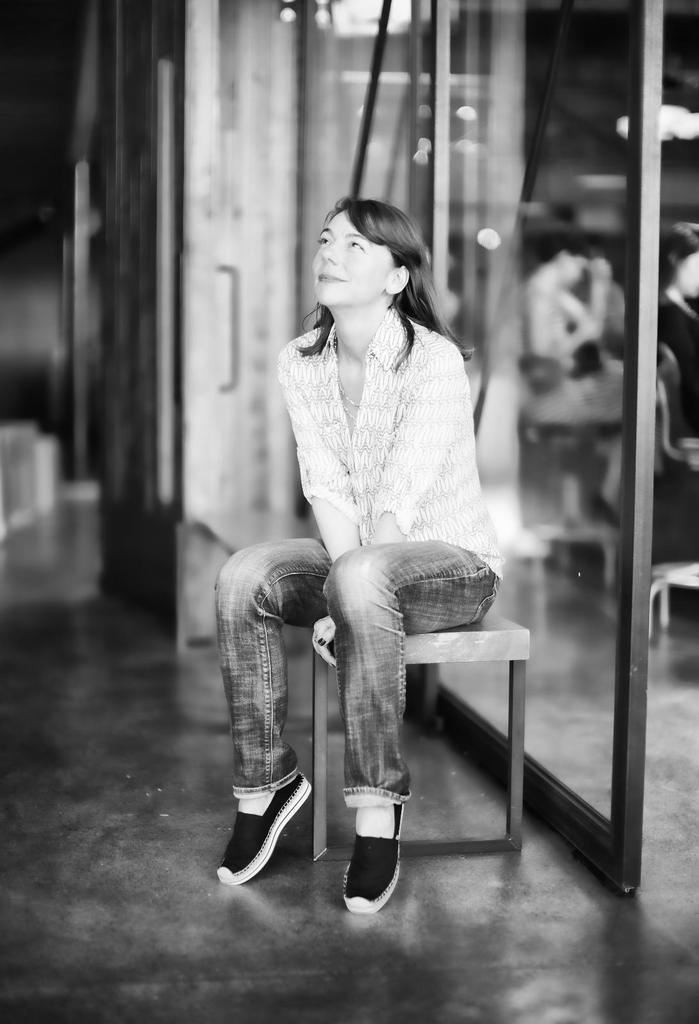What is the main subject of the image? The main subject of the image is a car. Where is the car located in the image? The car is parked on the side of the road. What can be seen in the background of the image? There are trees and a house in the background. How many horses can be seen hooked to the car in the image? There are no horses or hooks present in the image; it features a car parked on the side of the road with trees and a house in the background. 